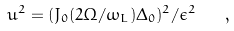<formula> <loc_0><loc_0><loc_500><loc_500>u ^ { 2 } = ( J _ { 0 } ( 2 \Omega / \omega _ { L } ) \Delta _ { 0 } ) ^ { 2 } / \epsilon ^ { 2 } \quad ,</formula> 